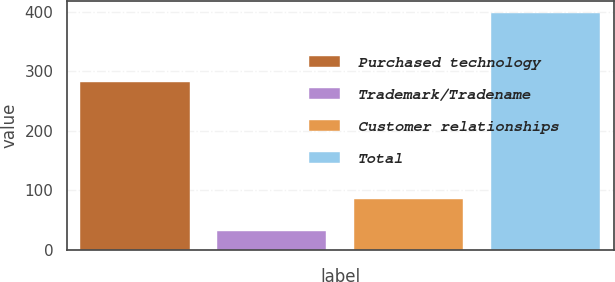<chart> <loc_0><loc_0><loc_500><loc_500><bar_chart><fcel>Purchased technology<fcel>Trademark/Tradename<fcel>Customer relationships<fcel>Total<nl><fcel>281<fcel>32<fcel>85<fcel>398<nl></chart> 